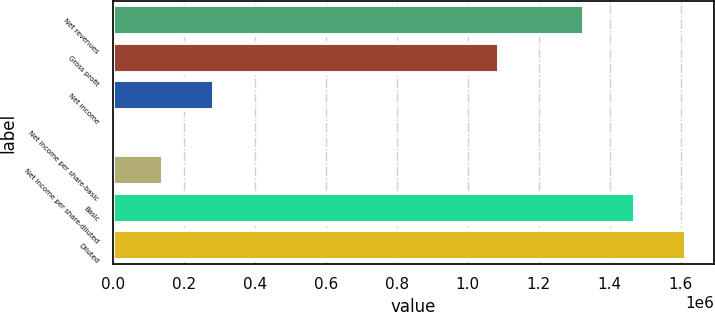Convert chart to OTSL. <chart><loc_0><loc_0><loc_500><loc_500><bar_chart><fcel>Net revenues<fcel>Gross profit<fcel>Net income<fcel>Net income per share-basic<fcel>Net income per share-diluted<fcel>Basic<fcel>Diluted<nl><fcel>1.32886e+06<fcel>1.08934e+06<fcel>285295<fcel>0.2<fcel>142648<fcel>1.47151e+06<fcel>1.61415e+06<nl></chart> 